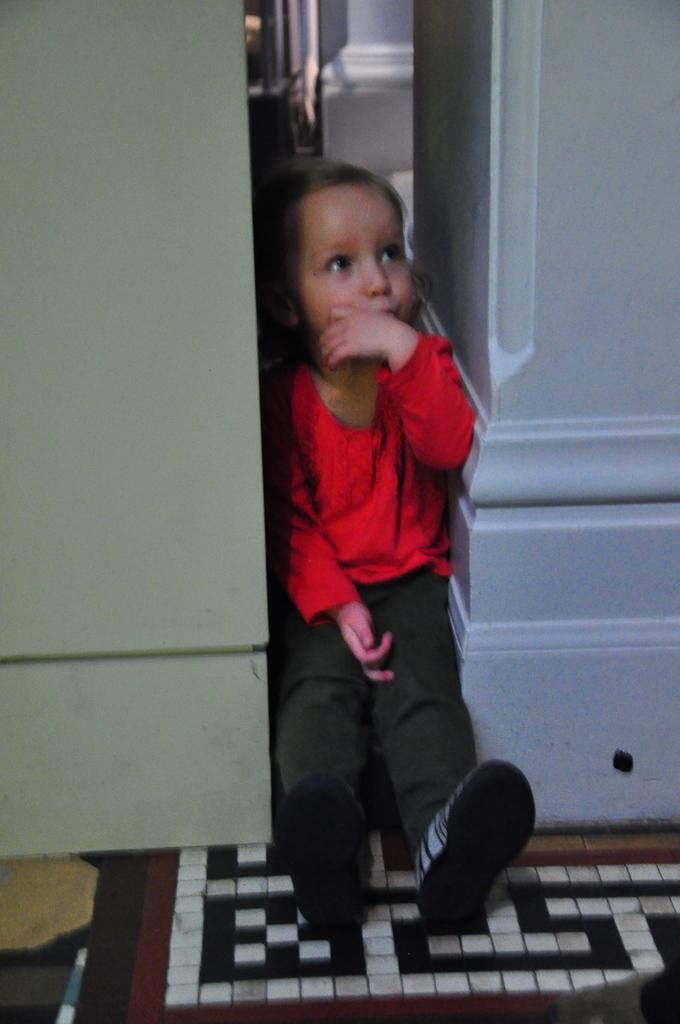How would you summarize this image in a sentence or two? In this image we can see a child wearing red dress and shoes is sitting in between the wall and some object. Here we can see the door mat on the floor. 